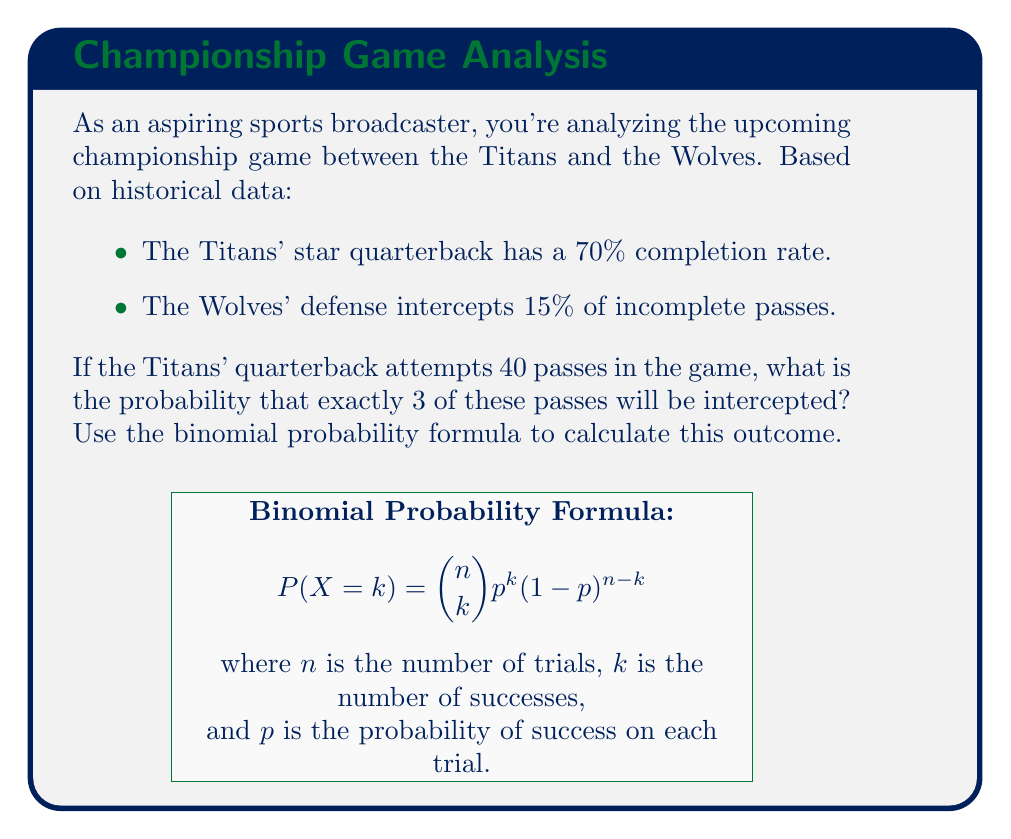Could you help me with this problem? Let's approach this step-by-step:

1) First, we need to calculate the probability of a single pass being intercepted:
   - Probability of incomplete pass = 1 - 0.70 = 0.30
   - Probability of interception given incomplete pass = 0.15
   - Probability of interception per pass attempt:
     $p = 0.30 \times 0.15 = 0.045$

2) Now we have:
   - $n$ (number of trials) = 40 passes
   - $k$ (number of successes) = 3 interceptions
   - $p$ (probability of success on each trial) = 0.045

3) We can use the binomial probability formula:

   $$ P(X = k) = \binom{n}{k} p^k (1-p)^{n-k} $$

4) Let's calculate each part:
   - $\binom{40}{3} = \frac{40!}{3!(40-3)!} = 9880$
   - $p^k = 0.045^3 = 0.000091125$
   - $(1-p)^{n-k} = 0.955^{37} = 0.1834403$

5) Putting it all together:

   $$ P(X = 3) = 9880 \times 0.000091125 \times 0.1834403 = 0.1653 $$

6) Therefore, the probability of exactly 3 interceptions in 40 pass attempts is approximately 0.1653 or 16.53%.
Answer: 0.1653 (or 16.53%) 